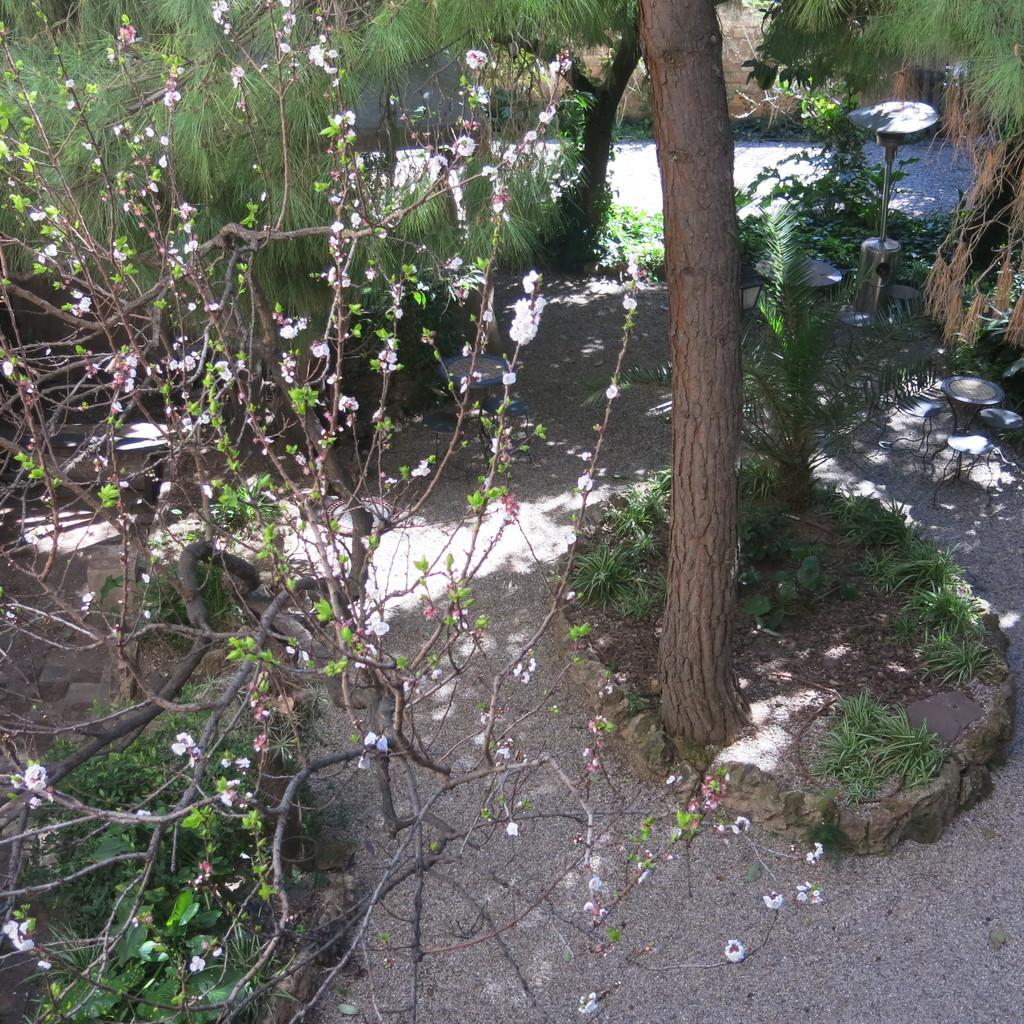What type of vegetation can be seen in the image? There is grass, plants, and trees in the image. Are there any specific features on the plants in the image? Yes, flowers are present on a plant in the front of the image. What type of respect can be seen being given to the plants in the image? There is no indication of respect being given to the plants in the image; it simply shows the plants and their features. 